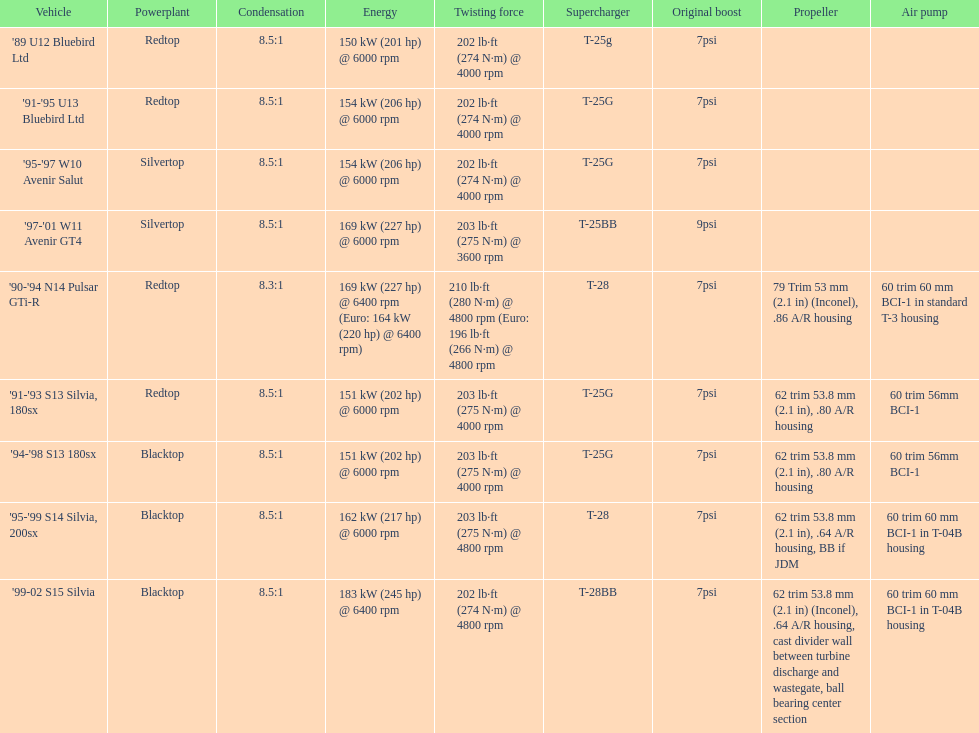Which car's power measured at higher than 6000 rpm? '90-'94 N14 Pulsar GTi-R, '99-02 S15 Silvia. 